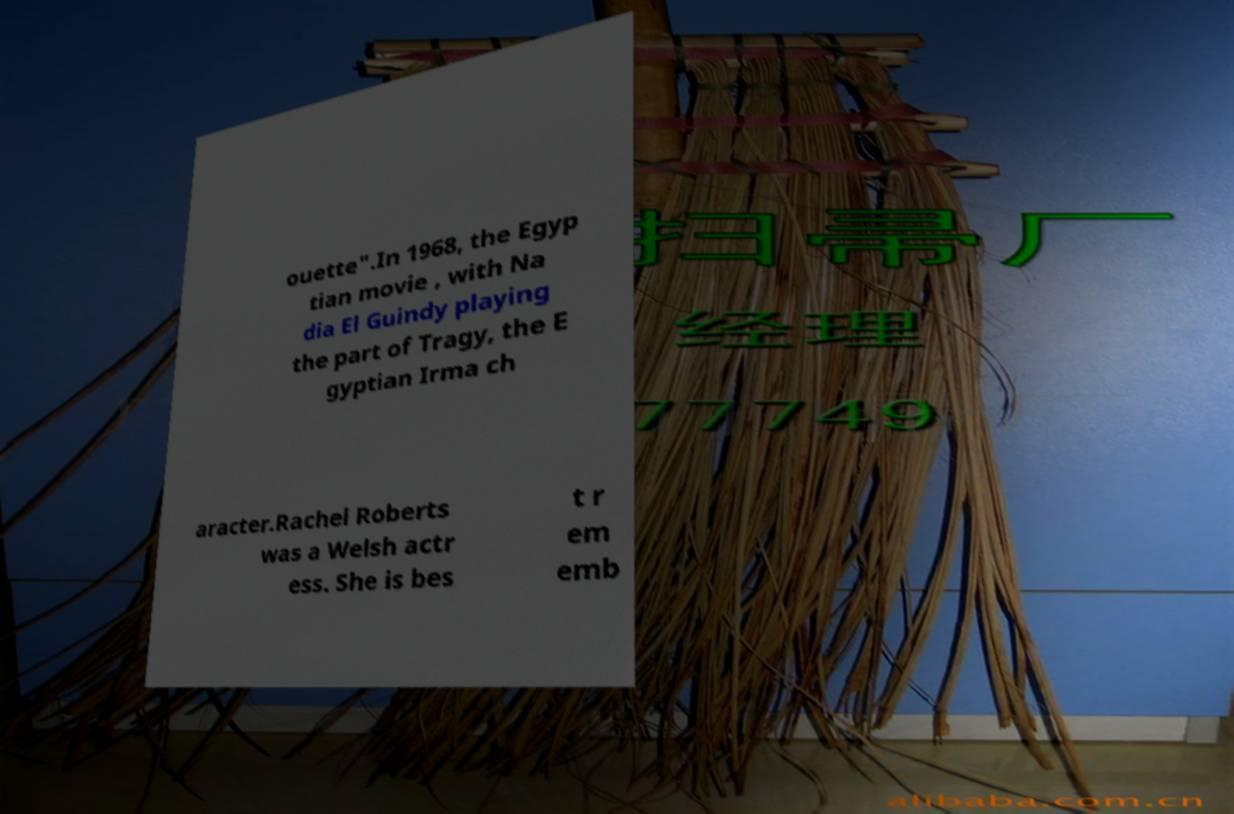Please read and relay the text visible in this image. What does it say? ouette".In 1968, the Egyp tian movie , with Na dia El Guindy playing the part of Tragy, the E gyptian Irma ch aracter.Rachel Roberts was a Welsh actr ess. She is bes t r em emb 